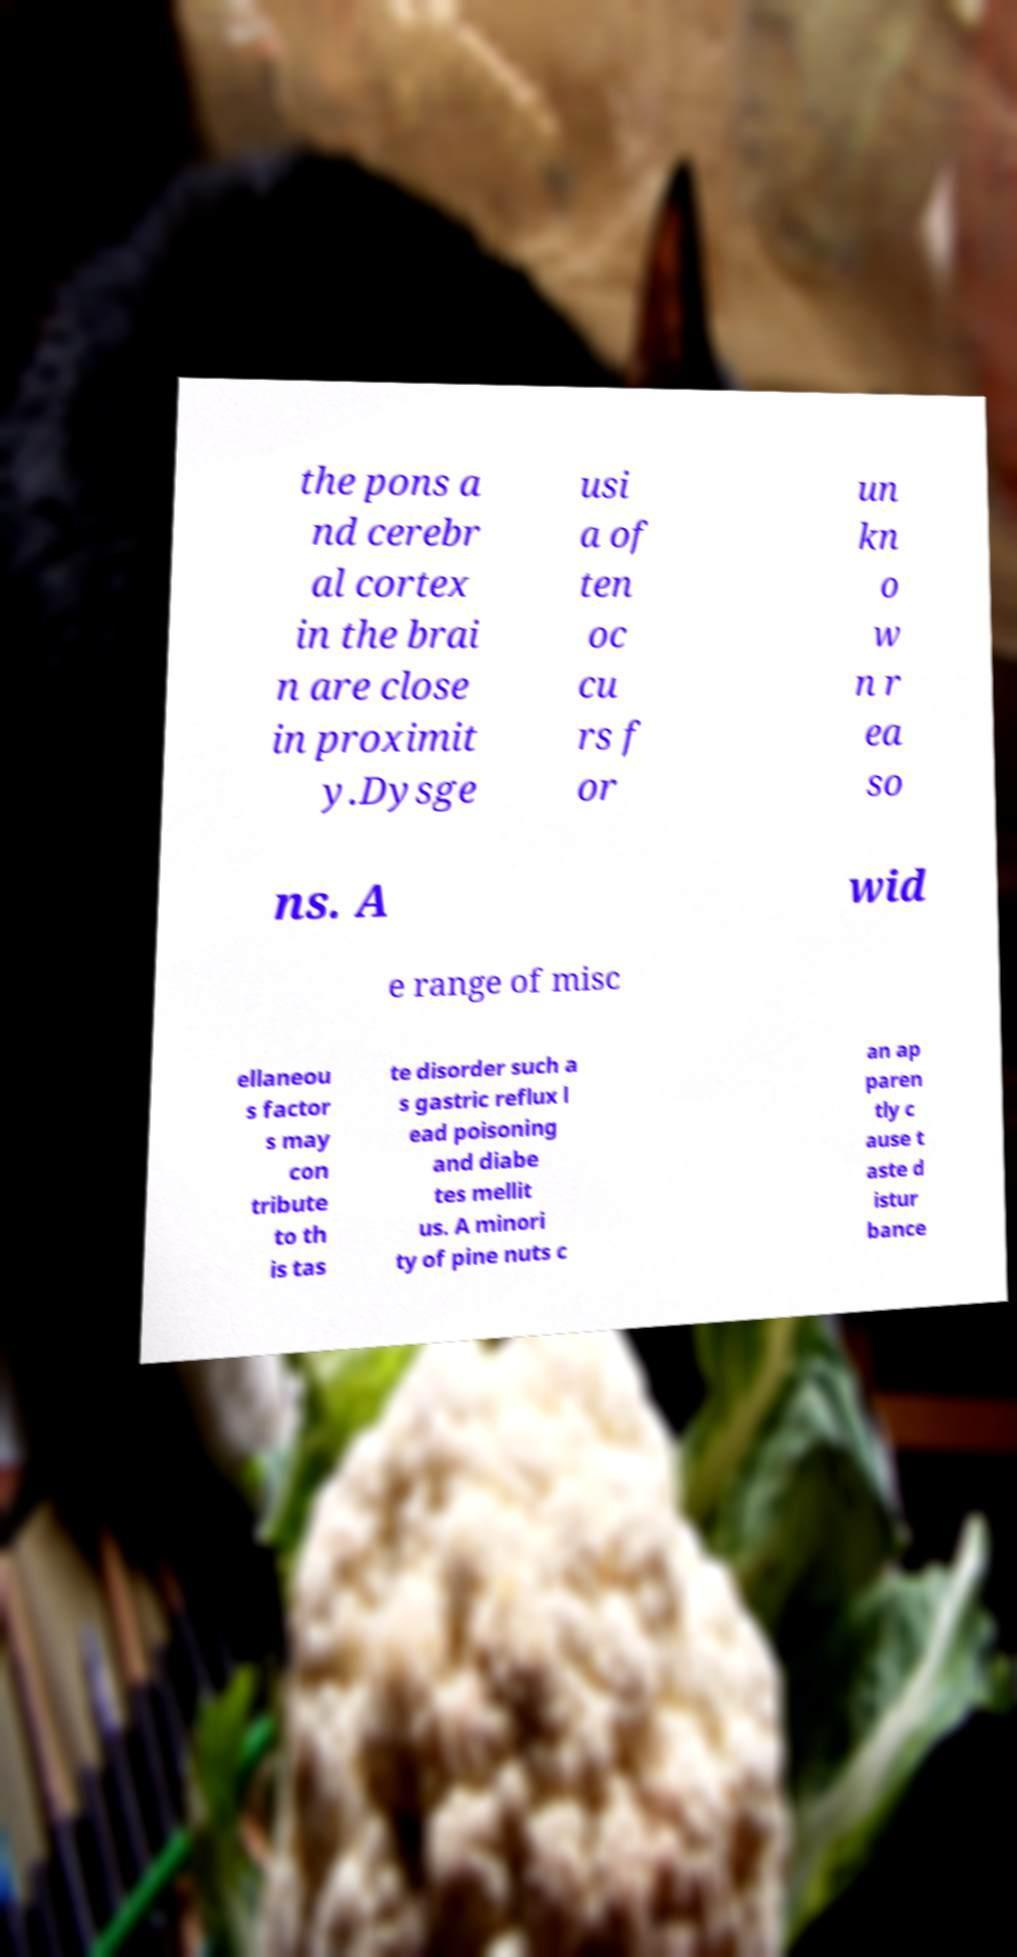I need the written content from this picture converted into text. Can you do that? the pons a nd cerebr al cortex in the brai n are close in proximit y.Dysge usi a of ten oc cu rs f or un kn o w n r ea so ns. A wid e range of misc ellaneou s factor s may con tribute to th is tas te disorder such a s gastric reflux l ead poisoning and diabe tes mellit us. A minori ty of pine nuts c an ap paren tly c ause t aste d istur bance 